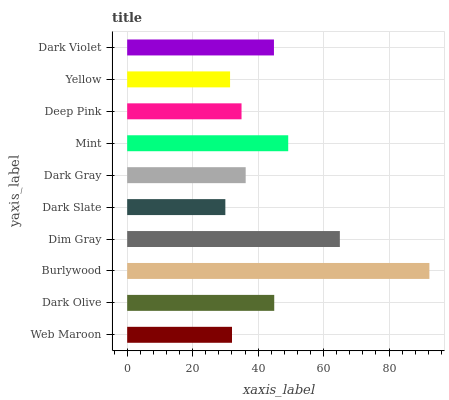Is Dark Slate the minimum?
Answer yes or no. Yes. Is Burlywood the maximum?
Answer yes or no. Yes. Is Dark Olive the minimum?
Answer yes or no. No. Is Dark Olive the maximum?
Answer yes or no. No. Is Dark Olive greater than Web Maroon?
Answer yes or no. Yes. Is Web Maroon less than Dark Olive?
Answer yes or no. Yes. Is Web Maroon greater than Dark Olive?
Answer yes or no. No. Is Dark Olive less than Web Maroon?
Answer yes or no. No. Is Dark Violet the high median?
Answer yes or no. Yes. Is Dark Gray the low median?
Answer yes or no. Yes. Is Dim Gray the high median?
Answer yes or no. No. Is Dim Gray the low median?
Answer yes or no. No. 